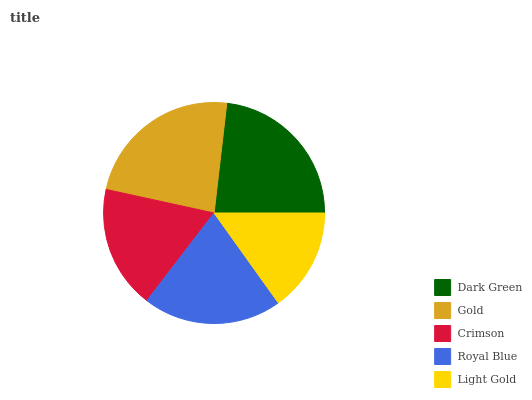Is Light Gold the minimum?
Answer yes or no. Yes. Is Gold the maximum?
Answer yes or no. Yes. Is Crimson the minimum?
Answer yes or no. No. Is Crimson the maximum?
Answer yes or no. No. Is Gold greater than Crimson?
Answer yes or no. Yes. Is Crimson less than Gold?
Answer yes or no. Yes. Is Crimson greater than Gold?
Answer yes or no. No. Is Gold less than Crimson?
Answer yes or no. No. Is Royal Blue the high median?
Answer yes or no. Yes. Is Royal Blue the low median?
Answer yes or no. Yes. Is Light Gold the high median?
Answer yes or no. No. Is Crimson the low median?
Answer yes or no. No. 